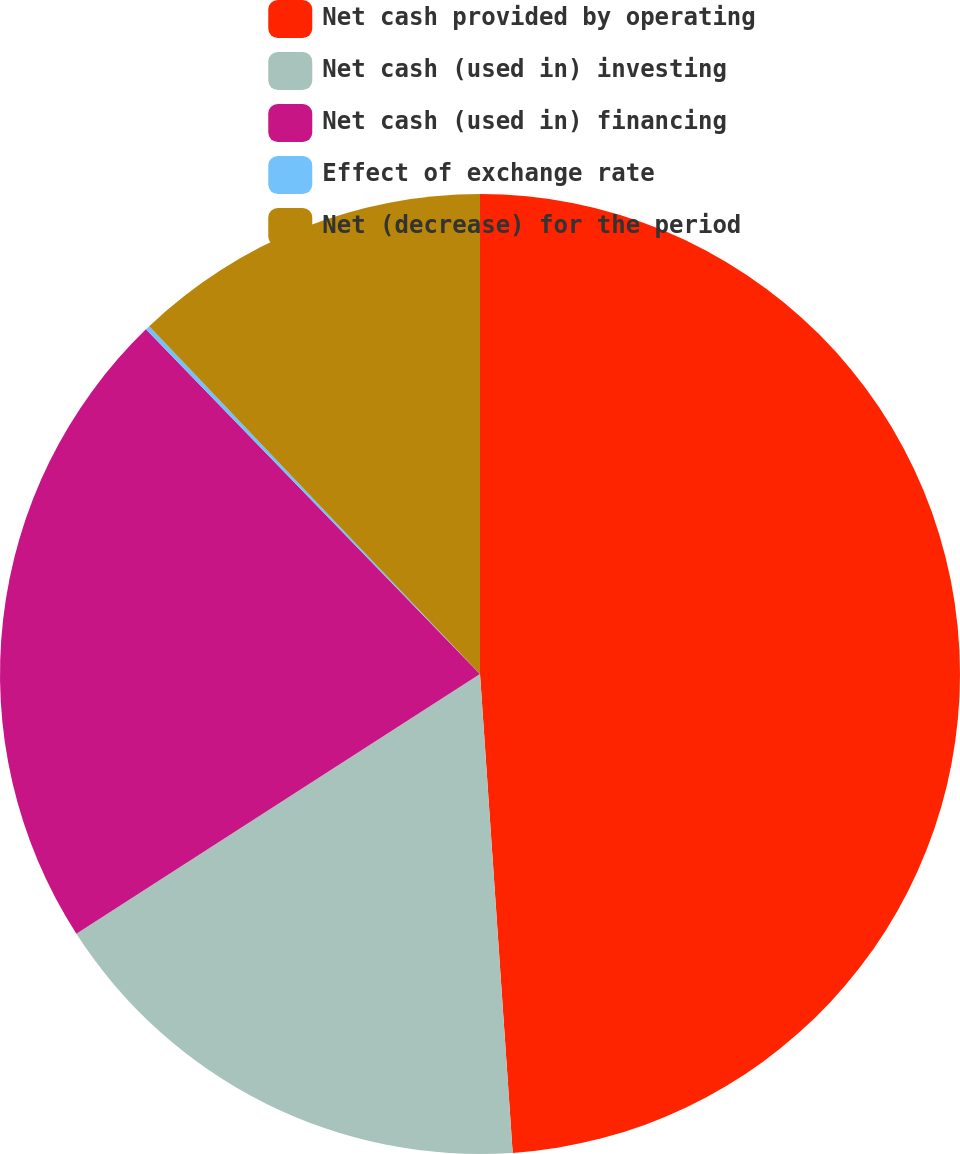Convert chart. <chart><loc_0><loc_0><loc_500><loc_500><pie_chart><fcel>Net cash provided by operating<fcel>Net cash (used in) investing<fcel>Net cash (used in) financing<fcel>Effect of exchange rate<fcel>Net (decrease) for the period<nl><fcel>48.91%<fcel>16.98%<fcel>21.85%<fcel>0.15%<fcel>12.1%<nl></chart> 